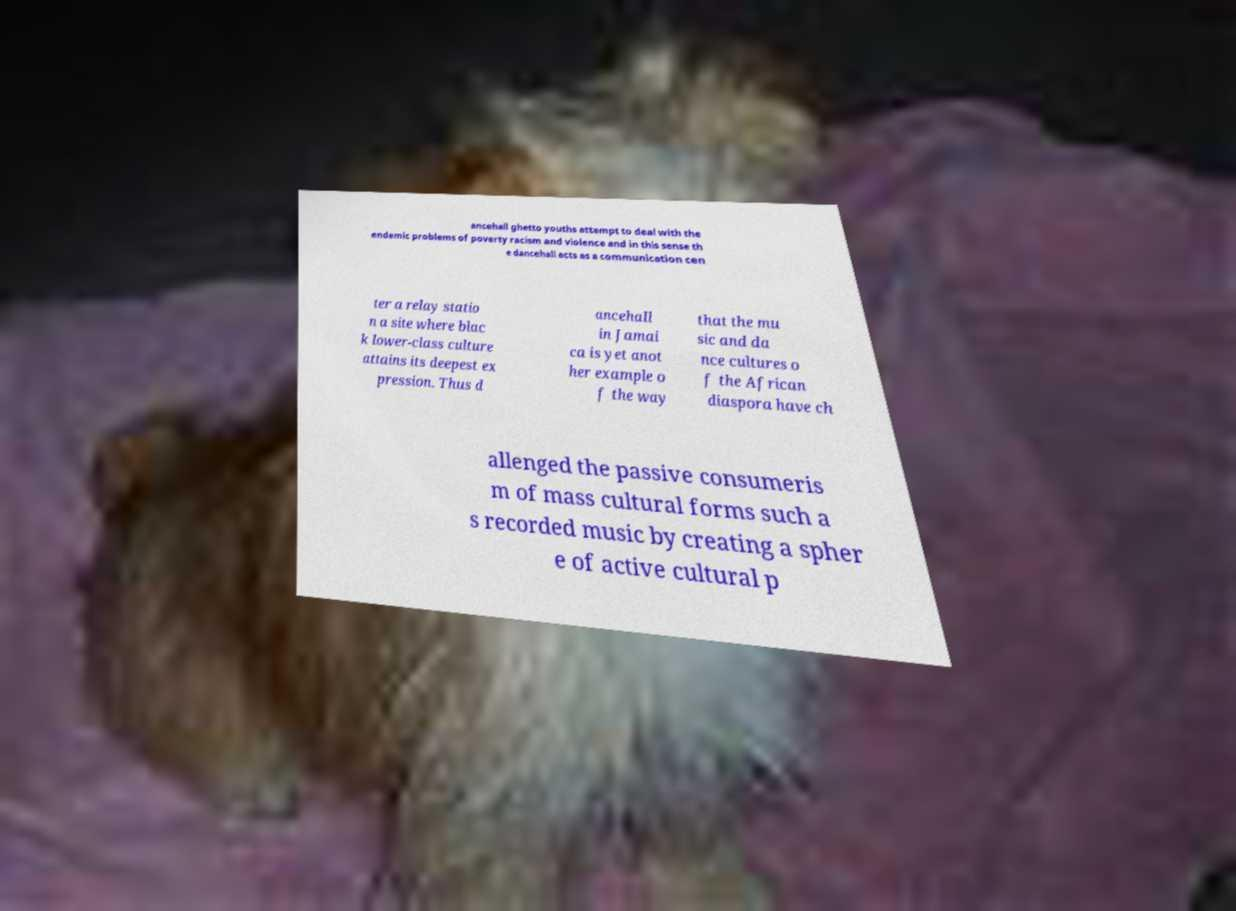Please read and relay the text visible in this image. What does it say? ancehall ghetto youths attempt to deal with the endemic problems of poverty racism and violence and in this sense th e dancehall acts as a communication cen ter a relay statio n a site where blac k lower-class culture attains its deepest ex pression. Thus d ancehall in Jamai ca is yet anot her example o f the way that the mu sic and da nce cultures o f the African diaspora have ch allenged the passive consumeris m of mass cultural forms such a s recorded music by creating a spher e of active cultural p 